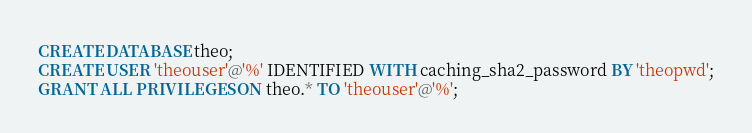<code> <loc_0><loc_0><loc_500><loc_500><_SQL_>CREATE DATABASE theo;
CREATE USER 'theouser'@'%' IDENTIFIED WITH caching_sha2_password BY 'theopwd';
GRANT ALL PRIVILEGES ON theo.* TO 'theouser'@'%';
</code> 